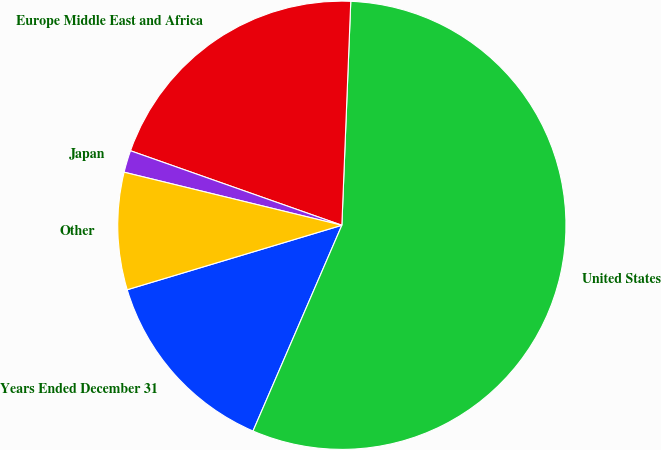Convert chart to OTSL. <chart><loc_0><loc_0><loc_500><loc_500><pie_chart><fcel>Years Ended December 31<fcel>United States<fcel>Europe Middle East and Africa<fcel>Japan<fcel>Other<nl><fcel>13.87%<fcel>55.86%<fcel>20.24%<fcel>1.59%<fcel>8.45%<nl></chart> 